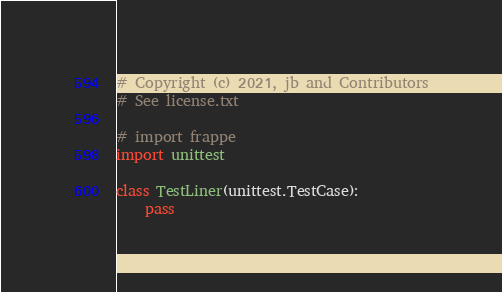Convert code to text. <code><loc_0><loc_0><loc_500><loc_500><_Python_># Copyright (c) 2021, jb and Contributors
# See license.txt

# import frappe
import unittest

class TestLiner(unittest.TestCase):
	pass
</code> 